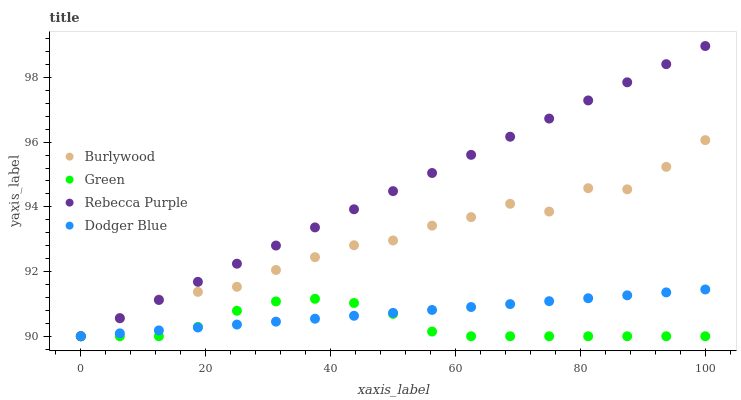Does Green have the minimum area under the curve?
Answer yes or no. Yes. Does Rebecca Purple have the maximum area under the curve?
Answer yes or no. Yes. Does Dodger Blue have the minimum area under the curve?
Answer yes or no. No. Does Dodger Blue have the maximum area under the curve?
Answer yes or no. No. Is Rebecca Purple the smoothest?
Answer yes or no. Yes. Is Burlywood the roughest?
Answer yes or no. Yes. Is Dodger Blue the smoothest?
Answer yes or no. No. Is Dodger Blue the roughest?
Answer yes or no. No. Does Burlywood have the lowest value?
Answer yes or no. Yes. Does Rebecca Purple have the highest value?
Answer yes or no. Yes. Does Dodger Blue have the highest value?
Answer yes or no. No. Does Burlywood intersect Dodger Blue?
Answer yes or no. Yes. Is Burlywood less than Dodger Blue?
Answer yes or no. No. Is Burlywood greater than Dodger Blue?
Answer yes or no. No. 